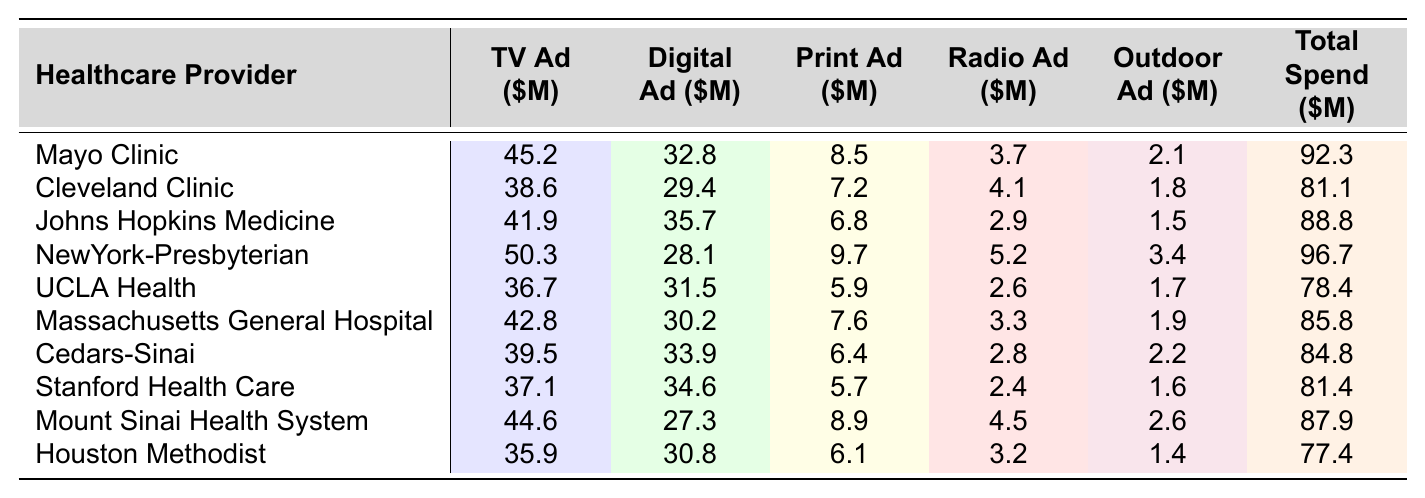What is the total advertising spend for Mayo Clinic? The table lists a total spend for each healthcare provider, and for Mayo Clinic, it shows a Total Spend of 92.3 million dollars.
Answer: 92.3 Which healthcare provider spent the most on digital advertising? By comparing the Digital Advertising amounts across the providers, NewYork-Presbyterian has the highest spend at 28.1 million dollars.
Answer: NewYork-Presbyterian What is the total spend for Cleveland Clinic and Johns Hopkins Medicine combined? The Total Spend for Cleveland Clinic is 81.1 million and for Johns Hopkins Medicine is 88.8 million. Adding these values gives 81.1 + 88.8 = 169.9 million.
Answer: 169.9 Did any healthcare provider spend more than 50 million on TV advertising? The table shows that NewYork-Presbyterian spent 50.3 million, which is greater than 50 million.
Answer: Yes What is the average spend on print advertising across all providers? To find the average, add all values in the Print Advertising column (8.5 + 7.2 + 6.8 + 9.7 + 5.9 + 7.6 + 6.4 + 5.7 + 8.9 + 6.1 = 70.4), then divide by the number of providers (10). Thus, the average is 70.4 / 10 = 7.04 million.
Answer: 7.04 Which provider has the highest total advertising spend? By examining the Total Spend column, NewYork-Presbyterian has the highest total spend of 96.7 million compared to others.
Answer: NewYork-Presbyterian What is the difference in TV advertising spend between Johns Hopkins Medicine and Massachusetts General Hospital? Johns Hopkins Medicine spent 41.9 million and Massachusetts General Hospital spent 42.8 million. The difference is 42.8 - 41.9 = 0.9 million.
Answer: 0.9 What percentage of total advertising spend does digital advertising represent for Cedars-Sinai? Cedars-Sinai spent 33.9 million on Digital Advertising and has a Total Spend of 84.8 million. The percentage is calculated as (33.9 / 84.8) * 100 = 39.97%, which rounds to 40%.
Answer: 40% Identify any two healthcare providers that spent less than 80 million in total advertising. Looking at the Total Spend column, UCLA Health (78.4 million) and Houston Methodist (77.4 million) both spent less than 80 million.
Answer: UCLA Health and Houston Methodist What is the total revenue from outdoor advertising across all providers? The Outdoor Advertising column totals 2.1 + 1.8 + 1.5 + 3.4 + 1.7 + 1.9 + 2.2 + 1.6 + 2.6 + 1.4 = 18.2 million.
Answer: 18.2 Which provider spent the least on radio advertising? By reviewing the values in the Radio Advertising column, Houston Methodist spent the least at 3.2 million.
Answer: Houston Methodist 